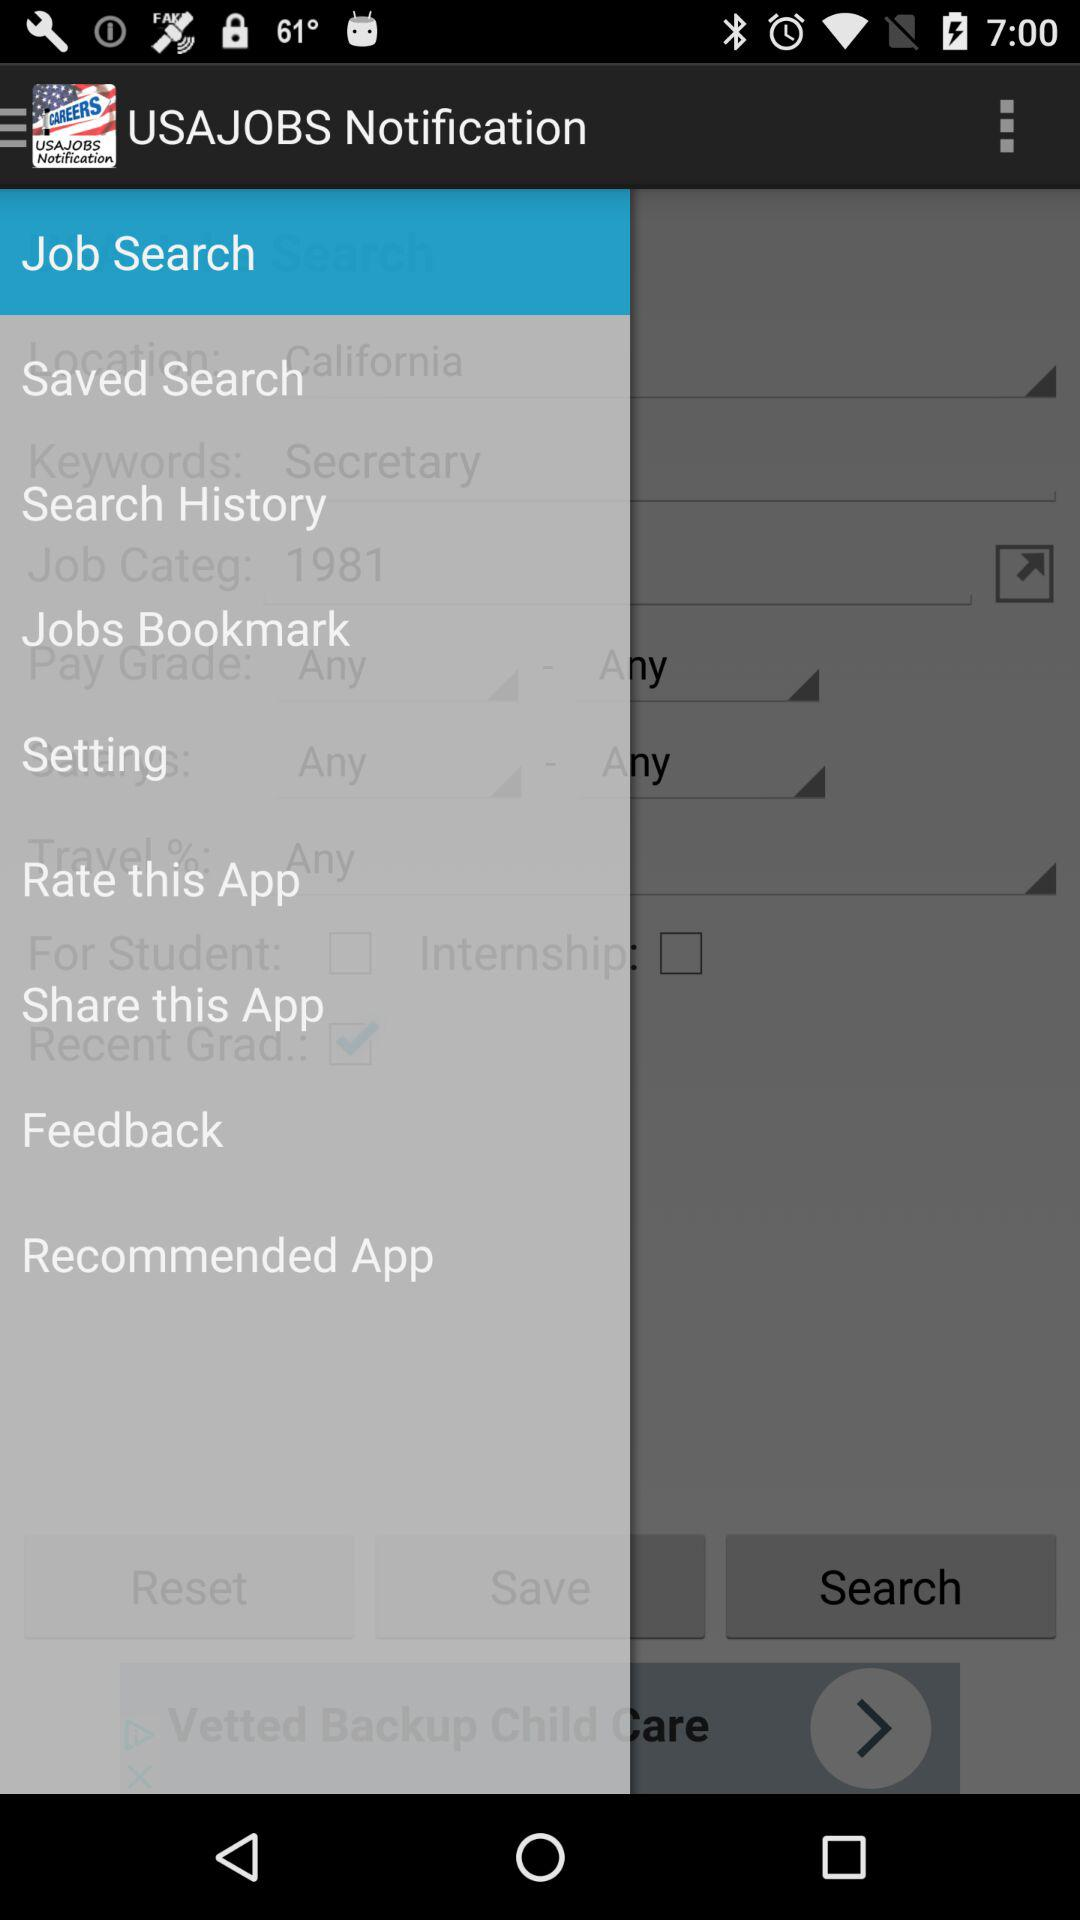What is the name of the application? The name of the application is "USAJOBS Notification". 